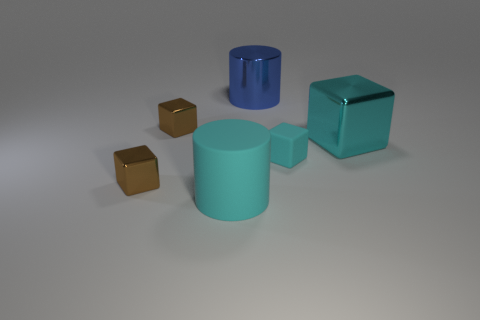Subtract all shiny blocks. How many blocks are left? 1 Subtract 2 cylinders. How many cylinders are left? 0 Add 3 purple blocks. How many objects exist? 9 Subtract all cyan cylinders. How many cylinders are left? 1 Subtract all cylinders. How many objects are left? 4 Subtract 0 red spheres. How many objects are left? 6 Subtract all purple cylinders. Subtract all gray blocks. How many cylinders are left? 2 Subtract all yellow spheres. How many yellow cubes are left? 0 Subtract all purple rubber blocks. Subtract all big metal cylinders. How many objects are left? 5 Add 2 small blocks. How many small blocks are left? 5 